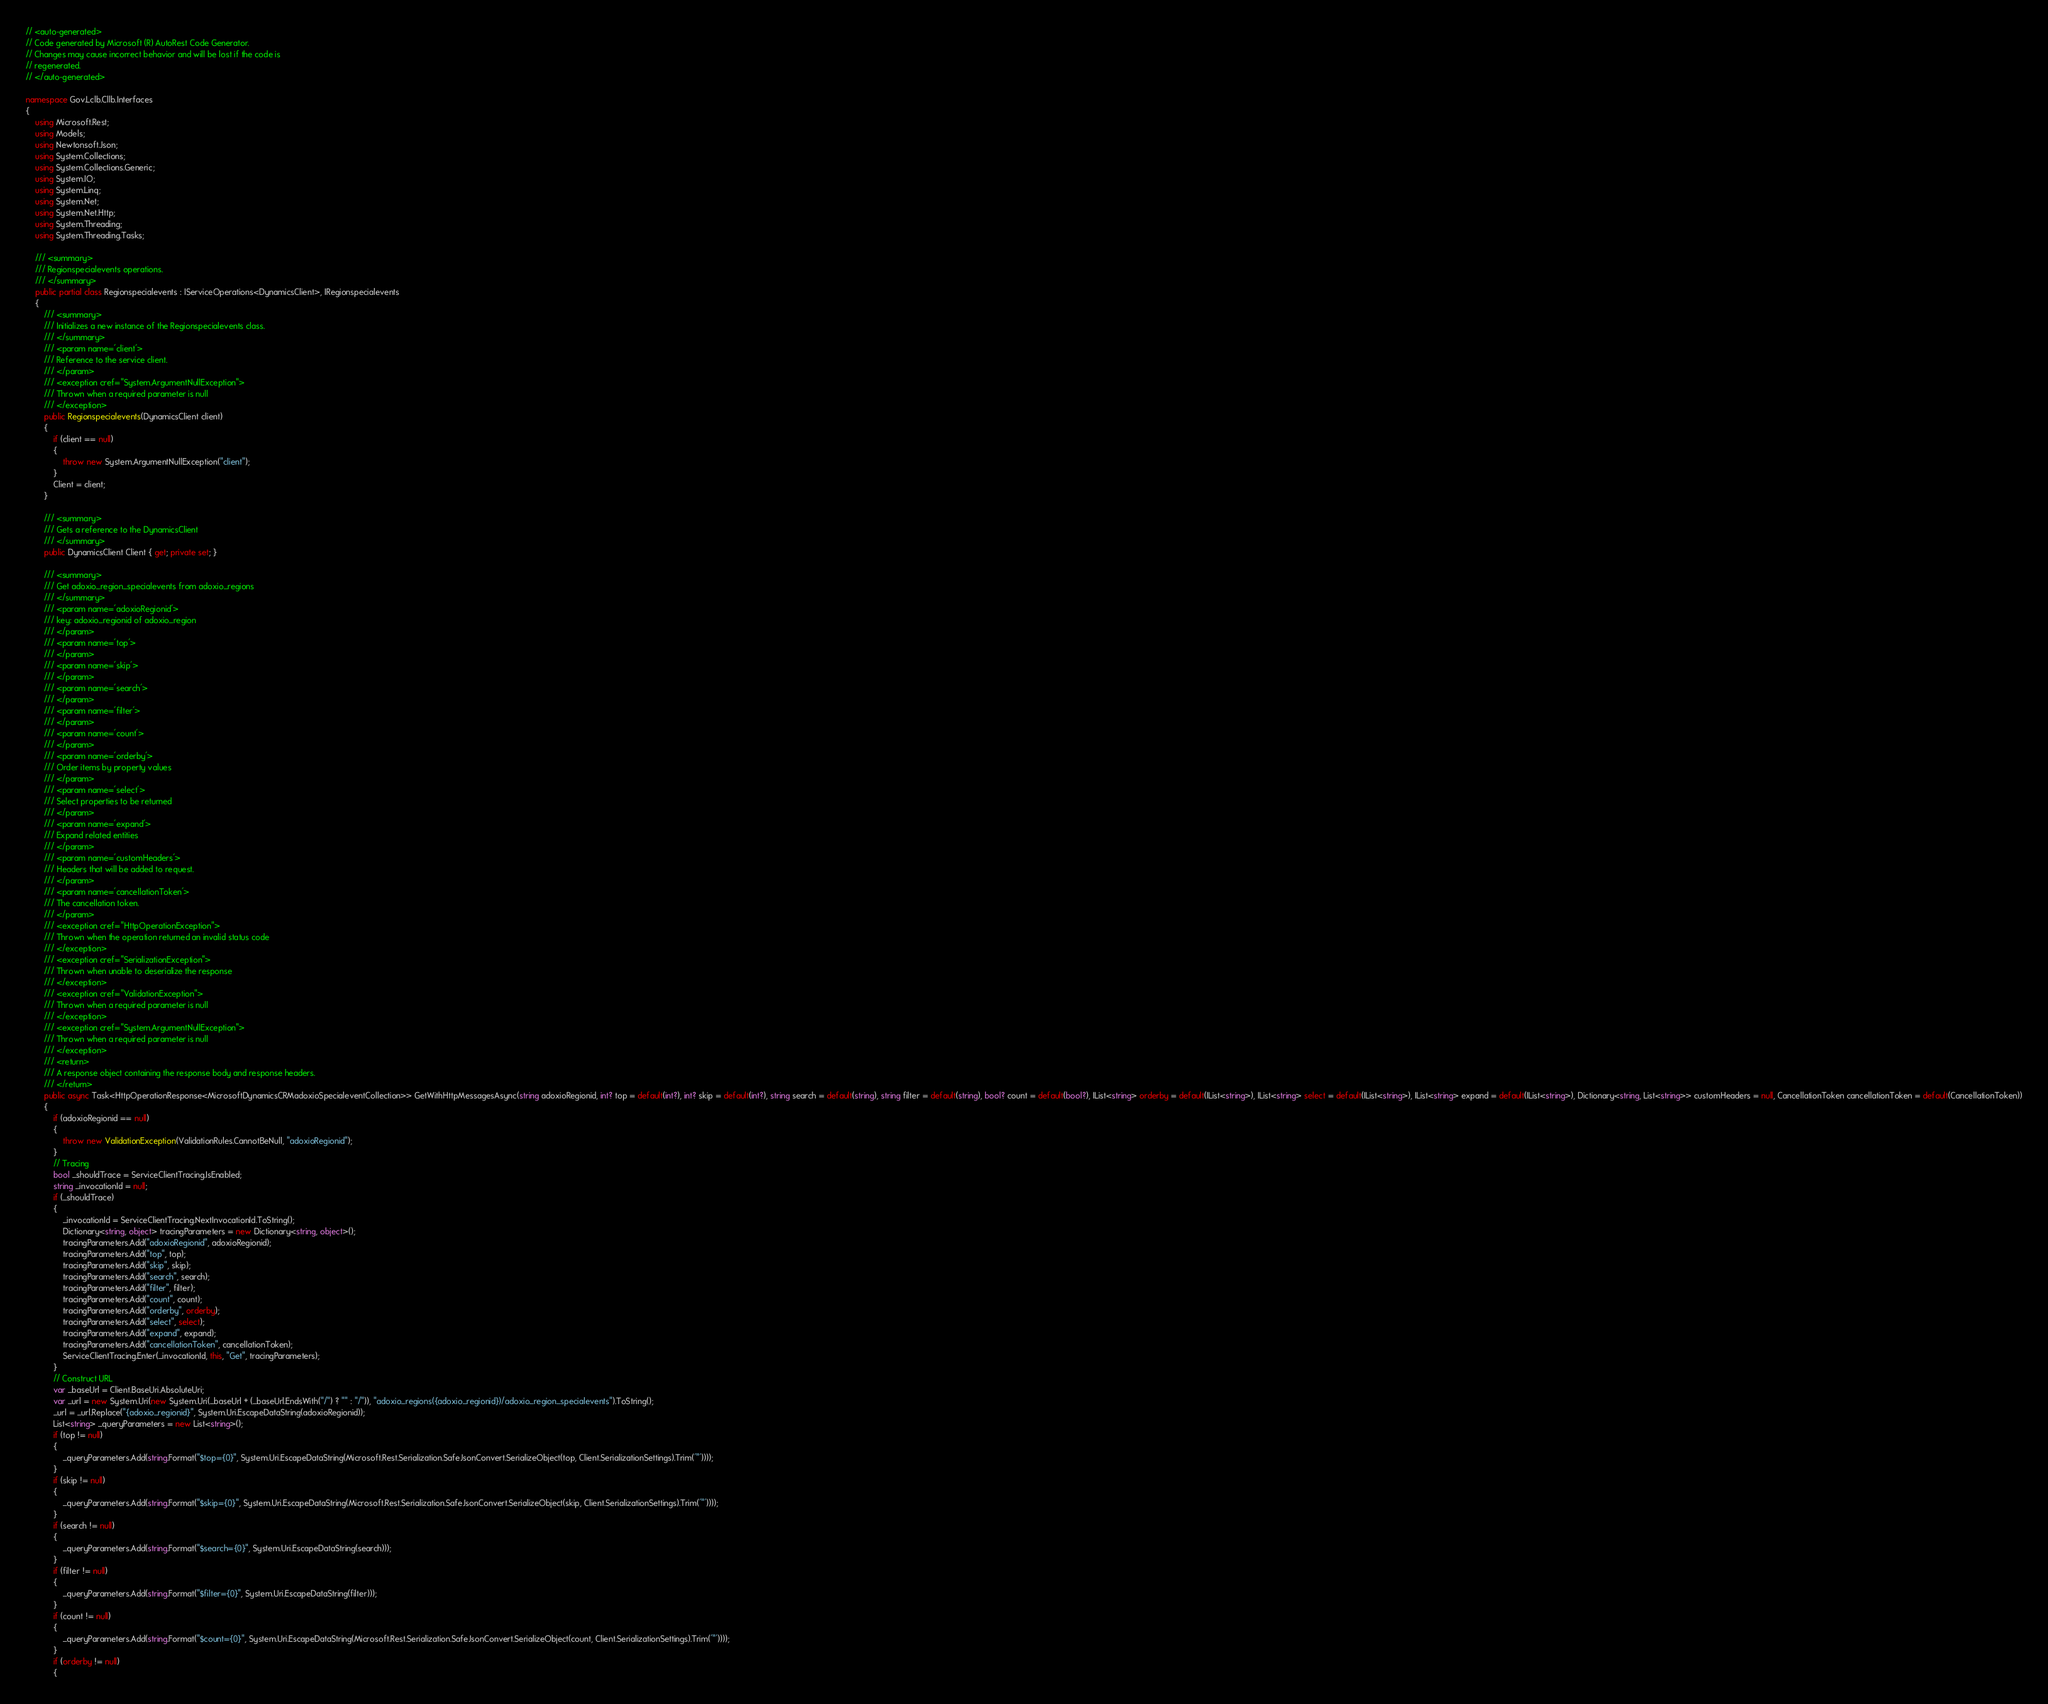Convert code to text. <code><loc_0><loc_0><loc_500><loc_500><_C#_>// <auto-generated>
// Code generated by Microsoft (R) AutoRest Code Generator.
// Changes may cause incorrect behavior and will be lost if the code is
// regenerated.
// </auto-generated>

namespace Gov.Lclb.Cllb.Interfaces
{
    using Microsoft.Rest;
    using Models;
    using Newtonsoft.Json;
    using System.Collections;
    using System.Collections.Generic;
    using System.IO;
    using System.Linq;
    using System.Net;
    using System.Net.Http;
    using System.Threading;
    using System.Threading.Tasks;

    /// <summary>
    /// Regionspecialevents operations.
    /// </summary>
    public partial class Regionspecialevents : IServiceOperations<DynamicsClient>, IRegionspecialevents
    {
        /// <summary>
        /// Initializes a new instance of the Regionspecialevents class.
        /// </summary>
        /// <param name='client'>
        /// Reference to the service client.
        /// </param>
        /// <exception cref="System.ArgumentNullException">
        /// Thrown when a required parameter is null
        /// </exception>
        public Regionspecialevents(DynamicsClient client)
        {
            if (client == null)
            {
                throw new System.ArgumentNullException("client");
            }
            Client = client;
        }

        /// <summary>
        /// Gets a reference to the DynamicsClient
        /// </summary>
        public DynamicsClient Client { get; private set; }

        /// <summary>
        /// Get adoxio_region_specialevents from adoxio_regions
        /// </summary>
        /// <param name='adoxioRegionid'>
        /// key: adoxio_regionid of adoxio_region
        /// </param>
        /// <param name='top'>
        /// </param>
        /// <param name='skip'>
        /// </param>
        /// <param name='search'>
        /// </param>
        /// <param name='filter'>
        /// </param>
        /// <param name='count'>
        /// </param>
        /// <param name='orderby'>
        /// Order items by property values
        /// </param>
        /// <param name='select'>
        /// Select properties to be returned
        /// </param>
        /// <param name='expand'>
        /// Expand related entities
        /// </param>
        /// <param name='customHeaders'>
        /// Headers that will be added to request.
        /// </param>
        /// <param name='cancellationToken'>
        /// The cancellation token.
        /// </param>
        /// <exception cref="HttpOperationException">
        /// Thrown when the operation returned an invalid status code
        /// </exception>
        /// <exception cref="SerializationException">
        /// Thrown when unable to deserialize the response
        /// </exception>
        /// <exception cref="ValidationException">
        /// Thrown when a required parameter is null
        /// </exception>
        /// <exception cref="System.ArgumentNullException">
        /// Thrown when a required parameter is null
        /// </exception>
        /// <return>
        /// A response object containing the response body and response headers.
        /// </return>
        public async Task<HttpOperationResponse<MicrosoftDynamicsCRMadoxioSpecialeventCollection>> GetWithHttpMessagesAsync(string adoxioRegionid, int? top = default(int?), int? skip = default(int?), string search = default(string), string filter = default(string), bool? count = default(bool?), IList<string> orderby = default(IList<string>), IList<string> select = default(IList<string>), IList<string> expand = default(IList<string>), Dictionary<string, List<string>> customHeaders = null, CancellationToken cancellationToken = default(CancellationToken))
        {
            if (adoxioRegionid == null)
            {
                throw new ValidationException(ValidationRules.CannotBeNull, "adoxioRegionid");
            }
            // Tracing
            bool _shouldTrace = ServiceClientTracing.IsEnabled;
            string _invocationId = null;
            if (_shouldTrace)
            {
                _invocationId = ServiceClientTracing.NextInvocationId.ToString();
                Dictionary<string, object> tracingParameters = new Dictionary<string, object>();
                tracingParameters.Add("adoxioRegionid", adoxioRegionid);
                tracingParameters.Add("top", top);
                tracingParameters.Add("skip", skip);
                tracingParameters.Add("search", search);
                tracingParameters.Add("filter", filter);
                tracingParameters.Add("count", count);
                tracingParameters.Add("orderby", orderby);
                tracingParameters.Add("select", select);
                tracingParameters.Add("expand", expand);
                tracingParameters.Add("cancellationToken", cancellationToken);
                ServiceClientTracing.Enter(_invocationId, this, "Get", tracingParameters);
            }
            // Construct URL
            var _baseUrl = Client.BaseUri.AbsoluteUri;
            var _url = new System.Uri(new System.Uri(_baseUrl + (_baseUrl.EndsWith("/") ? "" : "/")), "adoxio_regions({adoxio_regionid})/adoxio_region_specialevents").ToString();
            _url = _url.Replace("{adoxio_regionid}", System.Uri.EscapeDataString(adoxioRegionid));
            List<string> _queryParameters = new List<string>();
            if (top != null)
            {
                _queryParameters.Add(string.Format("$top={0}", System.Uri.EscapeDataString(Microsoft.Rest.Serialization.SafeJsonConvert.SerializeObject(top, Client.SerializationSettings).Trim('"'))));
            }
            if (skip != null)
            {
                _queryParameters.Add(string.Format("$skip={0}", System.Uri.EscapeDataString(Microsoft.Rest.Serialization.SafeJsonConvert.SerializeObject(skip, Client.SerializationSettings).Trim('"'))));
            }
            if (search != null)
            {
                _queryParameters.Add(string.Format("$search={0}", System.Uri.EscapeDataString(search)));
            }
            if (filter != null)
            {
                _queryParameters.Add(string.Format("$filter={0}", System.Uri.EscapeDataString(filter)));
            }
            if (count != null)
            {
                _queryParameters.Add(string.Format("$count={0}", System.Uri.EscapeDataString(Microsoft.Rest.Serialization.SafeJsonConvert.SerializeObject(count, Client.SerializationSettings).Trim('"'))));
            }
            if (orderby != null)
            {</code> 